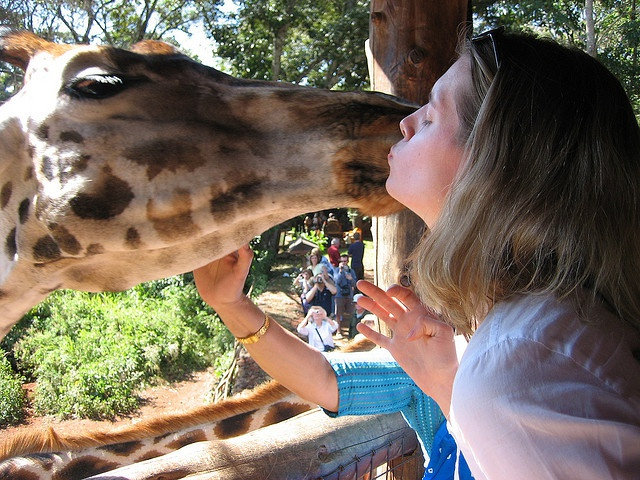Describe the objects in this image and their specific colors. I can see people in lavender, black, gray, darkgray, and lightpink tones, giraffe in lavender, black, gray, and maroon tones, people in lavender, tan, blue, salmon, and teal tones, people in lavender, gray, black, darkblue, and navy tones, and people in lavender, lightpink, darkgray, and pink tones in this image. 